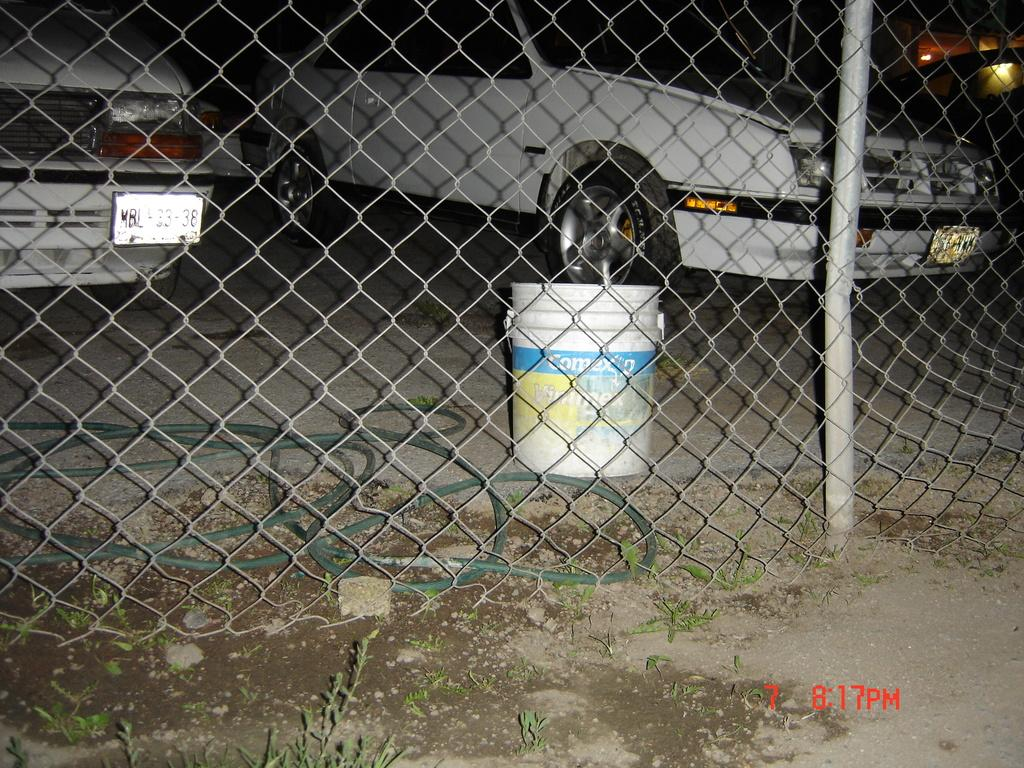What is located at the bottom of the image? There is a mesh at the bottom of the image. What can be seen in the background of the image? Cars and a bucket are visible in the background of the image. How many dinosaurs can be seen in the image? There are no dinosaurs present in the image. What type of ear is visible on the bucket in the image? There is no ear visible on the bucket in the image, as it is a bucket and not a living creature. 